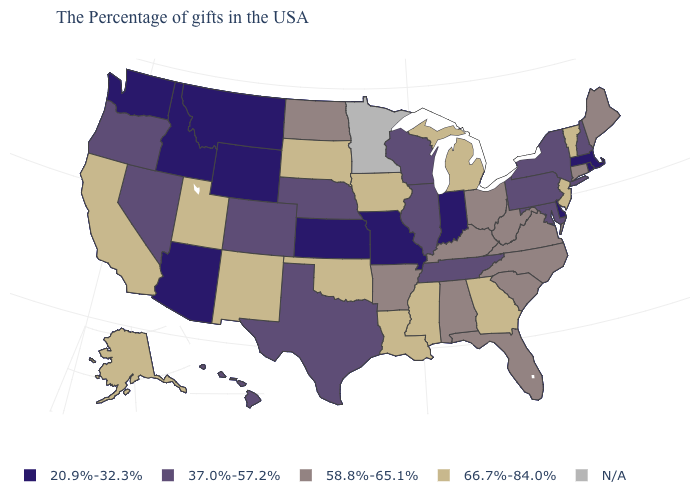What is the value of New Hampshire?
Short answer required. 37.0%-57.2%. Name the states that have a value in the range N/A?
Keep it brief. Minnesota. What is the value of Washington?
Write a very short answer. 20.9%-32.3%. What is the value of Arkansas?
Keep it brief. 58.8%-65.1%. What is the value of Arizona?
Short answer required. 20.9%-32.3%. Name the states that have a value in the range 37.0%-57.2%?
Be succinct. New Hampshire, New York, Maryland, Pennsylvania, Tennessee, Wisconsin, Illinois, Nebraska, Texas, Colorado, Nevada, Oregon, Hawaii. Is the legend a continuous bar?
Quick response, please. No. What is the value of Massachusetts?
Answer briefly. 20.9%-32.3%. Which states hav the highest value in the South?
Short answer required. Georgia, Mississippi, Louisiana, Oklahoma. Name the states that have a value in the range 20.9%-32.3%?
Quick response, please. Massachusetts, Rhode Island, Delaware, Indiana, Missouri, Kansas, Wyoming, Montana, Arizona, Idaho, Washington. Does the map have missing data?
Answer briefly. Yes. Among the states that border Nevada , does Utah have the highest value?
Short answer required. Yes. Among the states that border Idaho , does Montana have the lowest value?
Write a very short answer. Yes. Name the states that have a value in the range 66.7%-84.0%?
Give a very brief answer. Vermont, New Jersey, Georgia, Michigan, Mississippi, Louisiana, Iowa, Oklahoma, South Dakota, New Mexico, Utah, California, Alaska. Among the states that border Kentucky , does Indiana have the lowest value?
Give a very brief answer. Yes. 